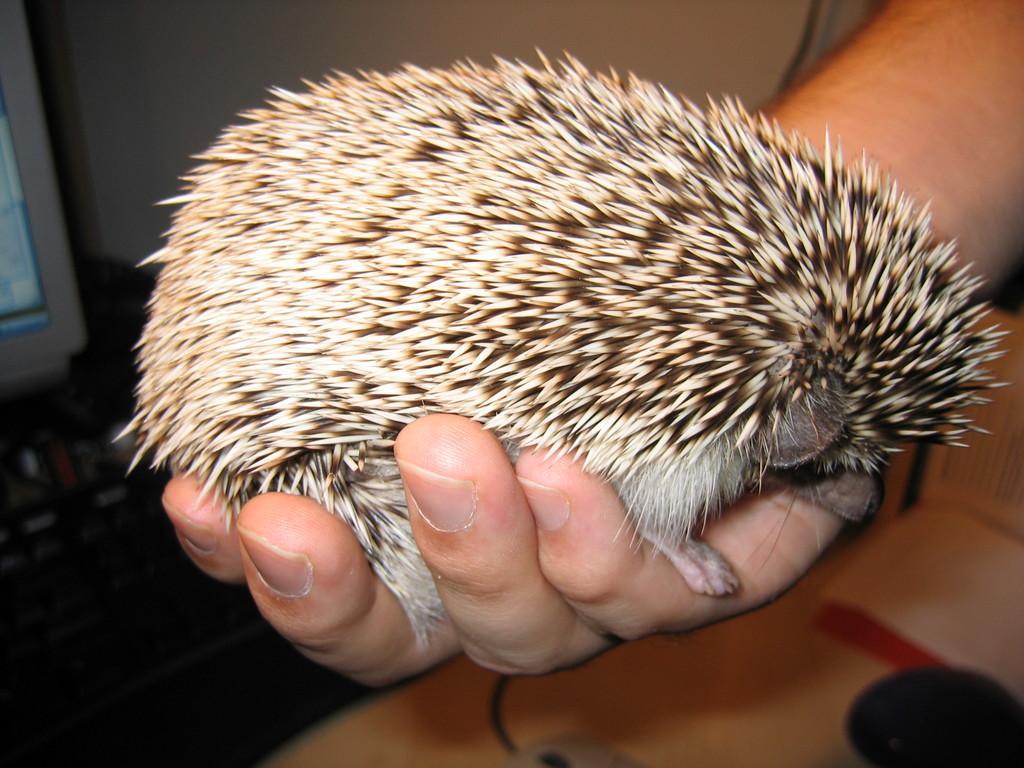Describe this image in one or two sentences. In this image I can see a person's hand which is holding an animal and at the bottom I can see a table , on the table I can see a book and the wall visible at the top. 